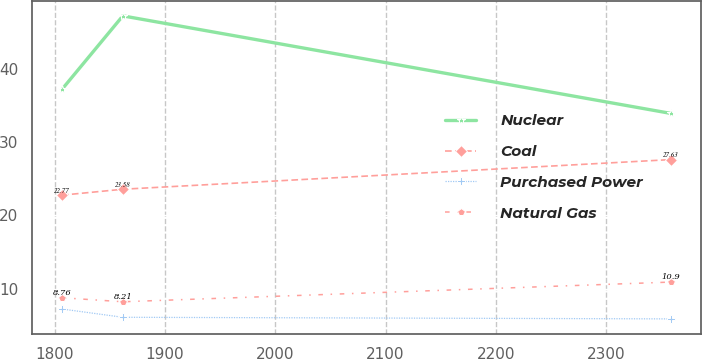<chart> <loc_0><loc_0><loc_500><loc_500><line_chart><ecel><fcel>Nuclear<fcel>Coal<fcel>Purchased Power<fcel>Natural Gas<nl><fcel>1806.53<fcel>37.22<fcel>22.77<fcel>7.22<fcel>8.76<nl><fcel>1861.73<fcel>47.26<fcel>23.58<fcel>6.09<fcel>8.21<nl><fcel>2358.51<fcel>33.94<fcel>27.63<fcel>5.87<fcel>10.9<nl></chart> 